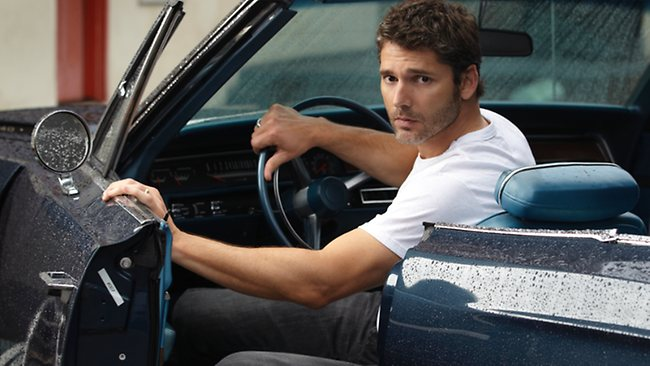What might the mood or story be behind this scenario? The scene appears charged with a pensive mood, as if the person is on the verge of embarking on a significant journey or reflecting on an important decision. His serious expression and the solitary setting contribute to a storyline filled with introspection and anticipation. 